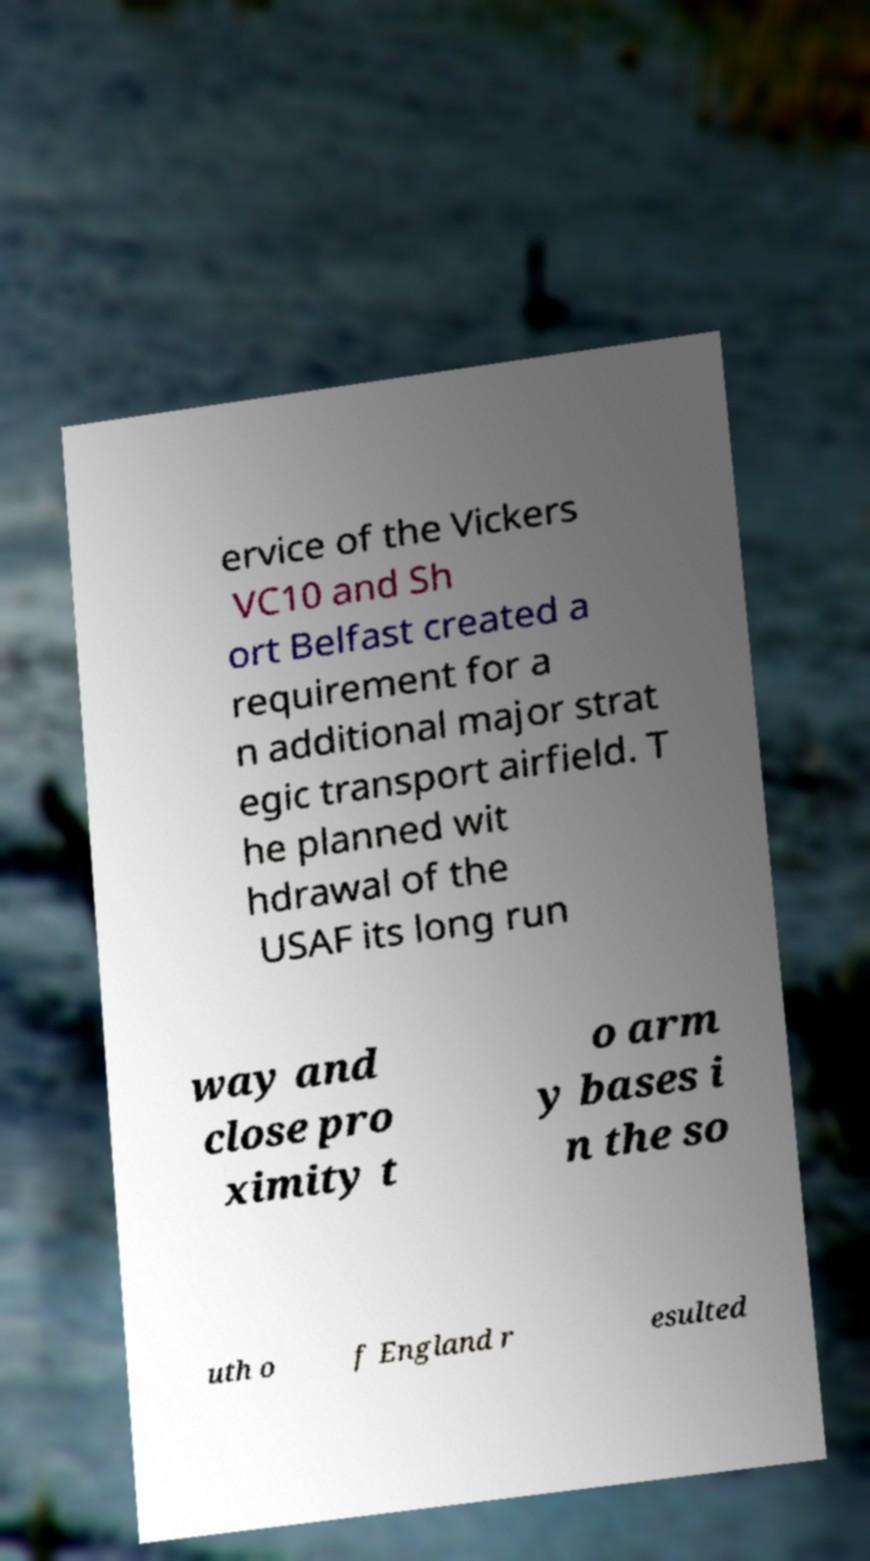Please read and relay the text visible in this image. What does it say? ervice of the Vickers VC10 and Sh ort Belfast created a requirement for a n additional major strat egic transport airfield. T he planned wit hdrawal of the USAF its long run way and close pro ximity t o arm y bases i n the so uth o f England r esulted 